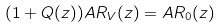Convert formula to latex. <formula><loc_0><loc_0><loc_500><loc_500>( 1 + Q ( z ) ) A R _ { V } ( z ) = A R _ { 0 } ( z )</formula> 